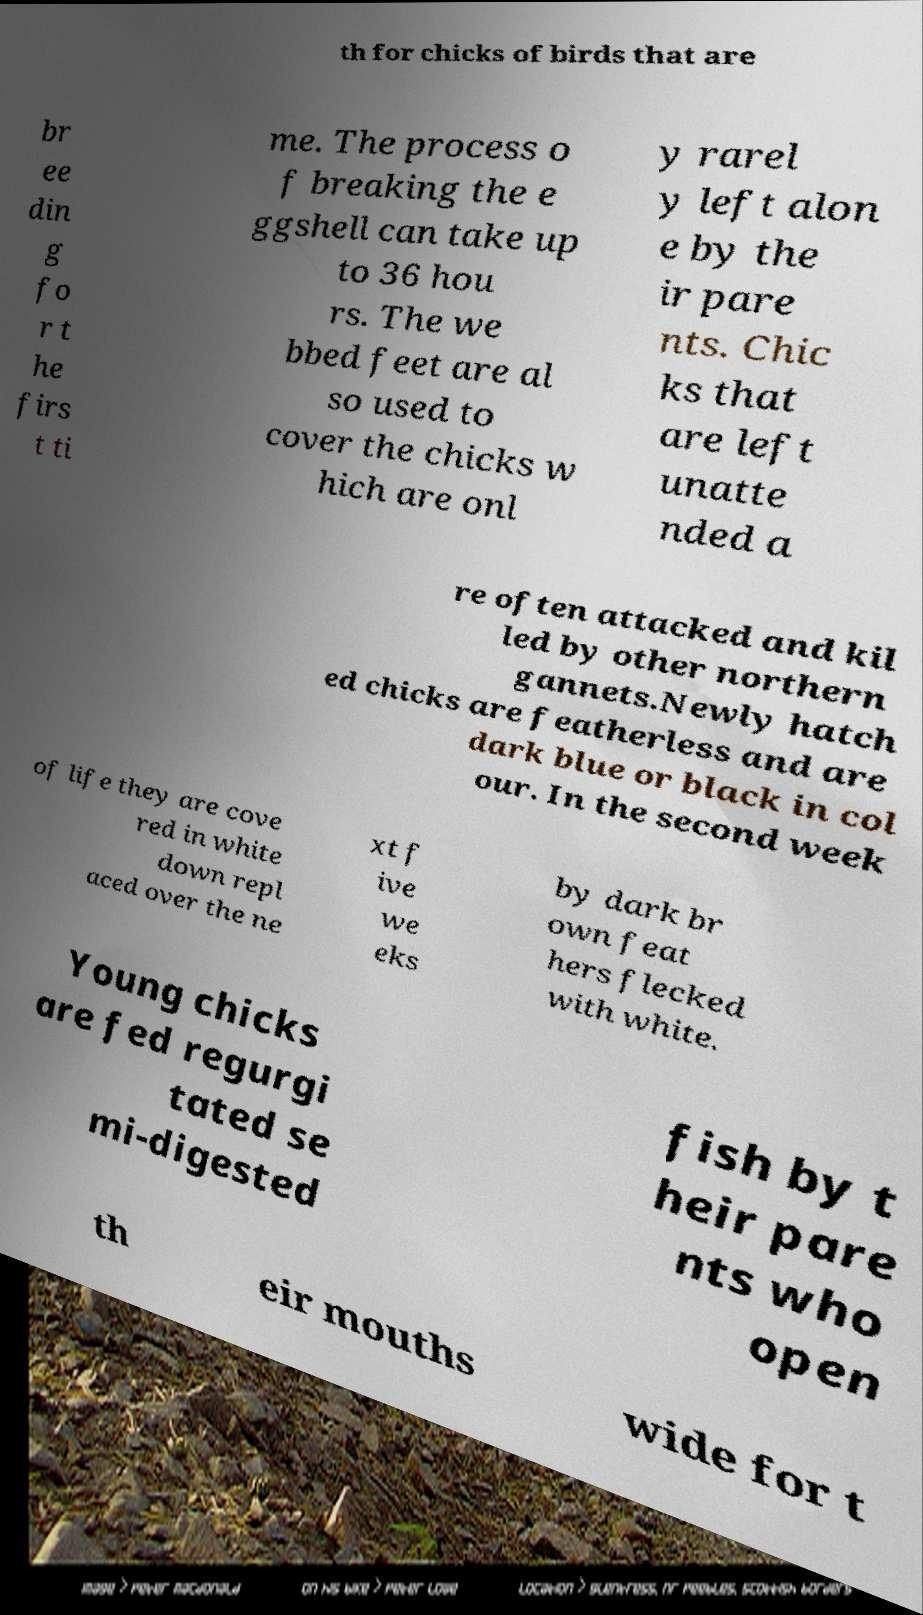Please read and relay the text visible in this image. What does it say? th for chicks of birds that are br ee din g fo r t he firs t ti me. The process o f breaking the e ggshell can take up to 36 hou rs. The we bbed feet are al so used to cover the chicks w hich are onl y rarel y left alon e by the ir pare nts. Chic ks that are left unatte nded a re often attacked and kil led by other northern gannets.Newly hatch ed chicks are featherless and are dark blue or black in col our. In the second week of life they are cove red in white down repl aced over the ne xt f ive we eks by dark br own feat hers flecked with white. Young chicks are fed regurgi tated se mi-digested fish by t heir pare nts who open th eir mouths wide for t 